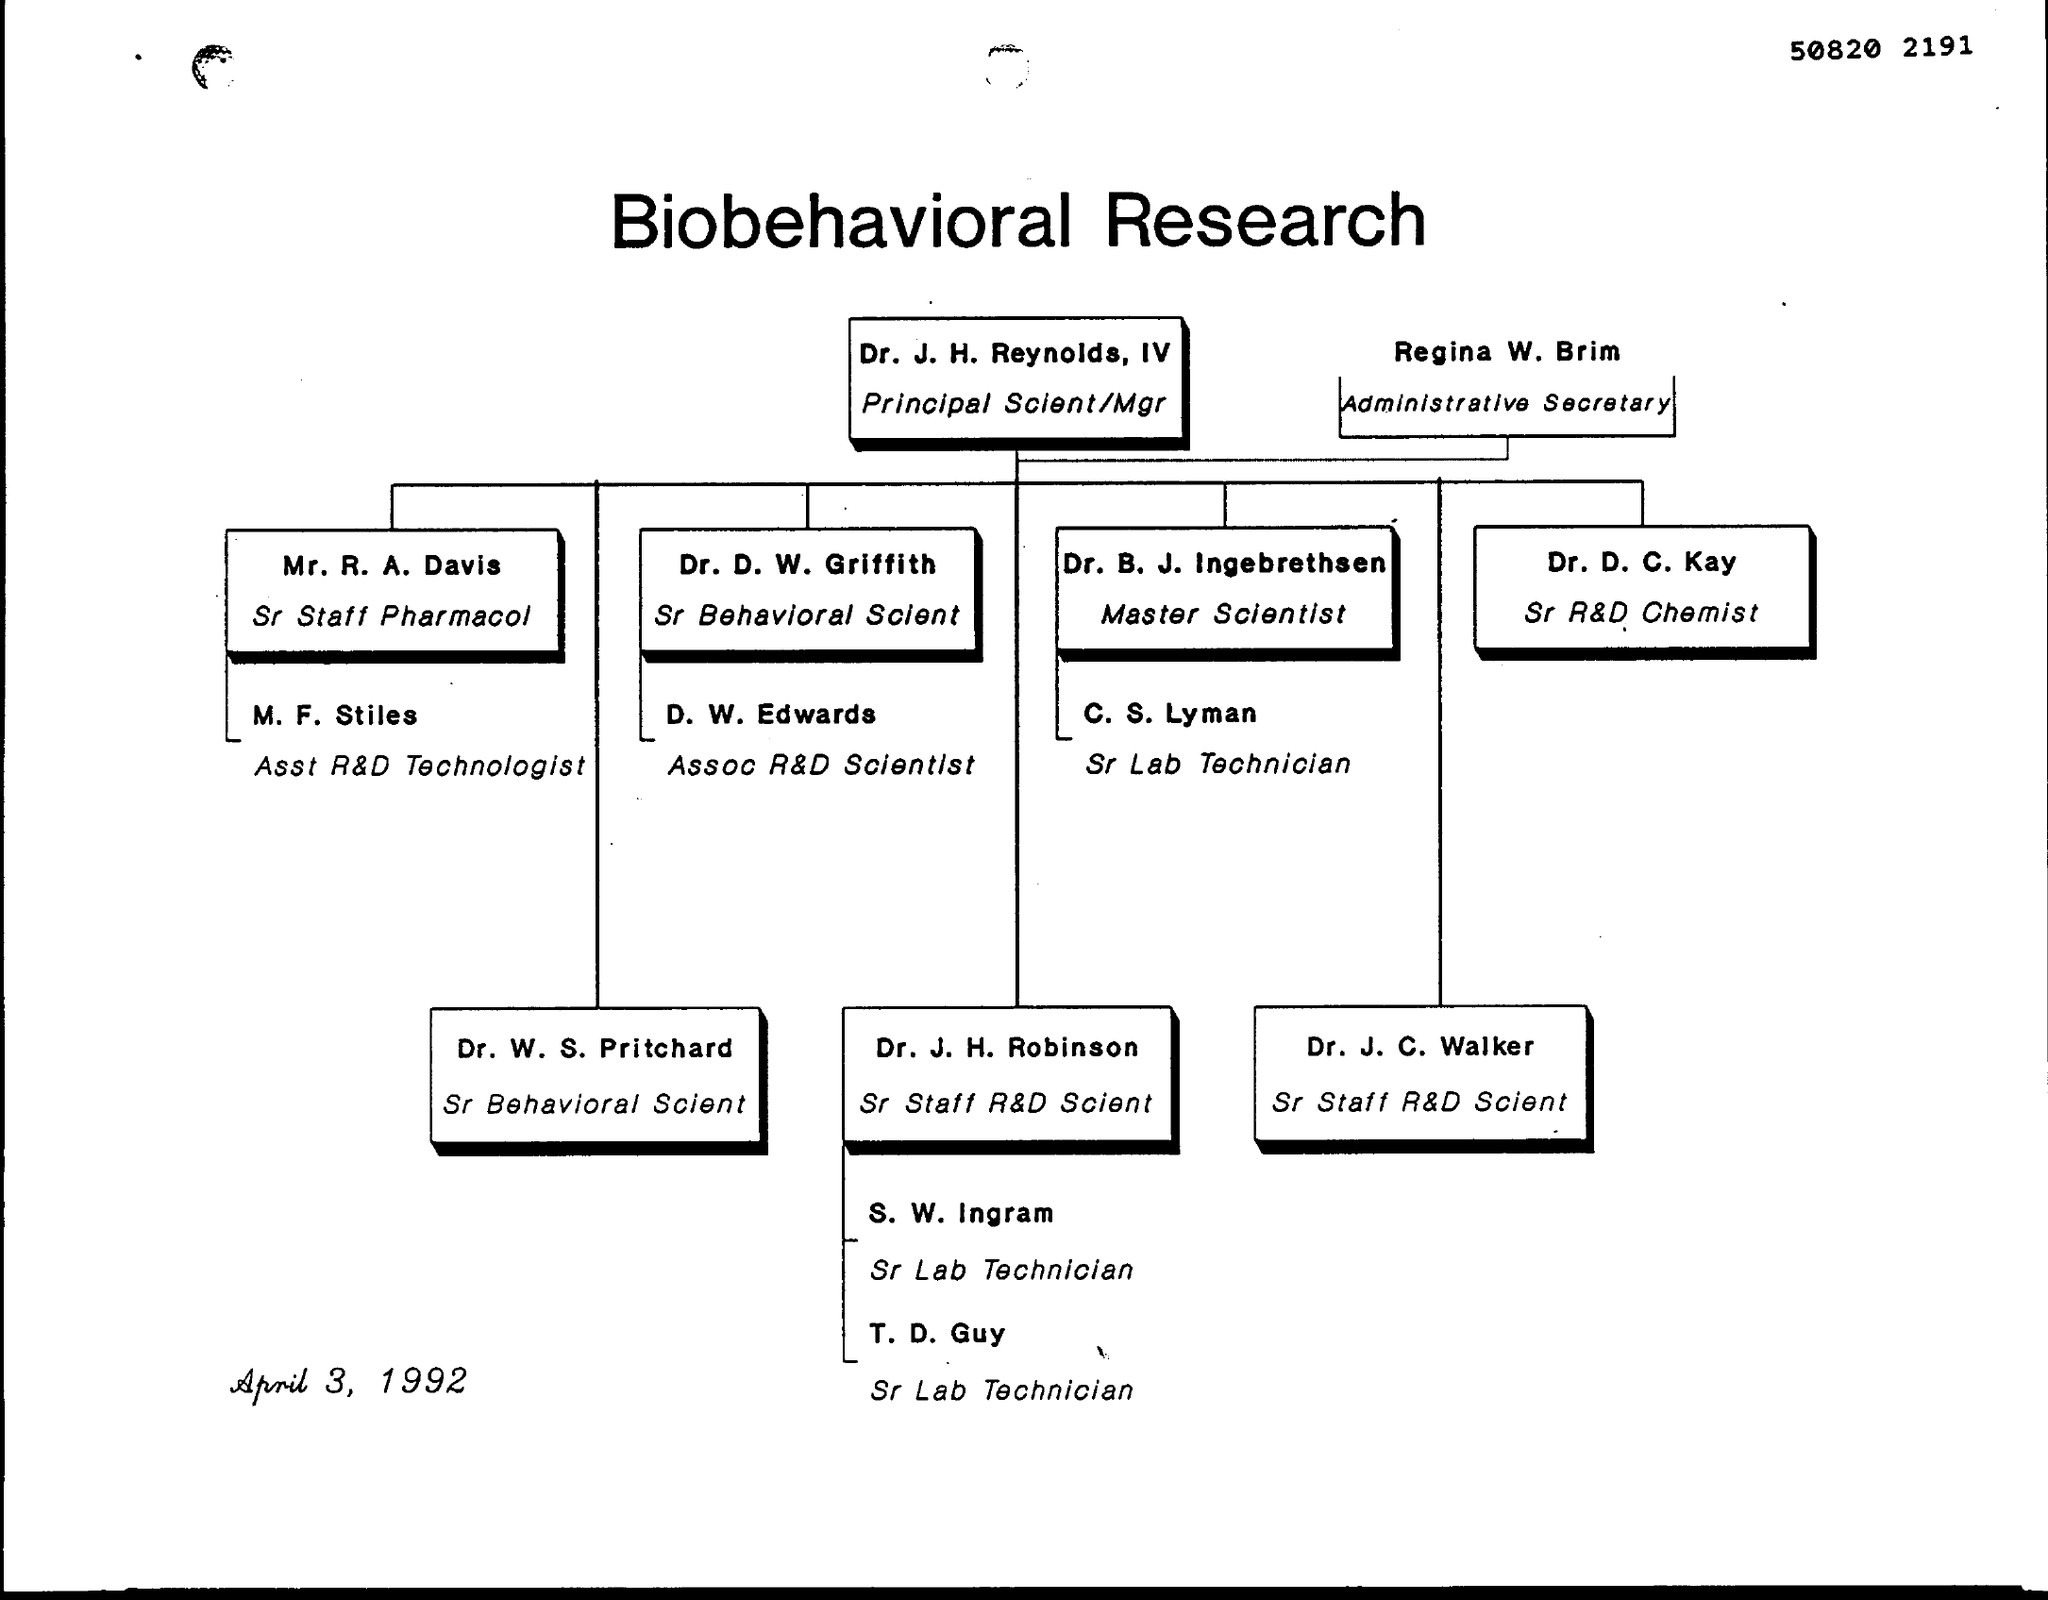What is the name of Sr Lab Technician under Master Scientist?
Your answer should be compact. C. S. Lyman. Who was Administrative Secretary?
Make the answer very short. Regina W. Brim. Dr.J. H. Reynolds, IV was working as?
Ensure brevity in your answer.  Principal Scient/Mgr. 